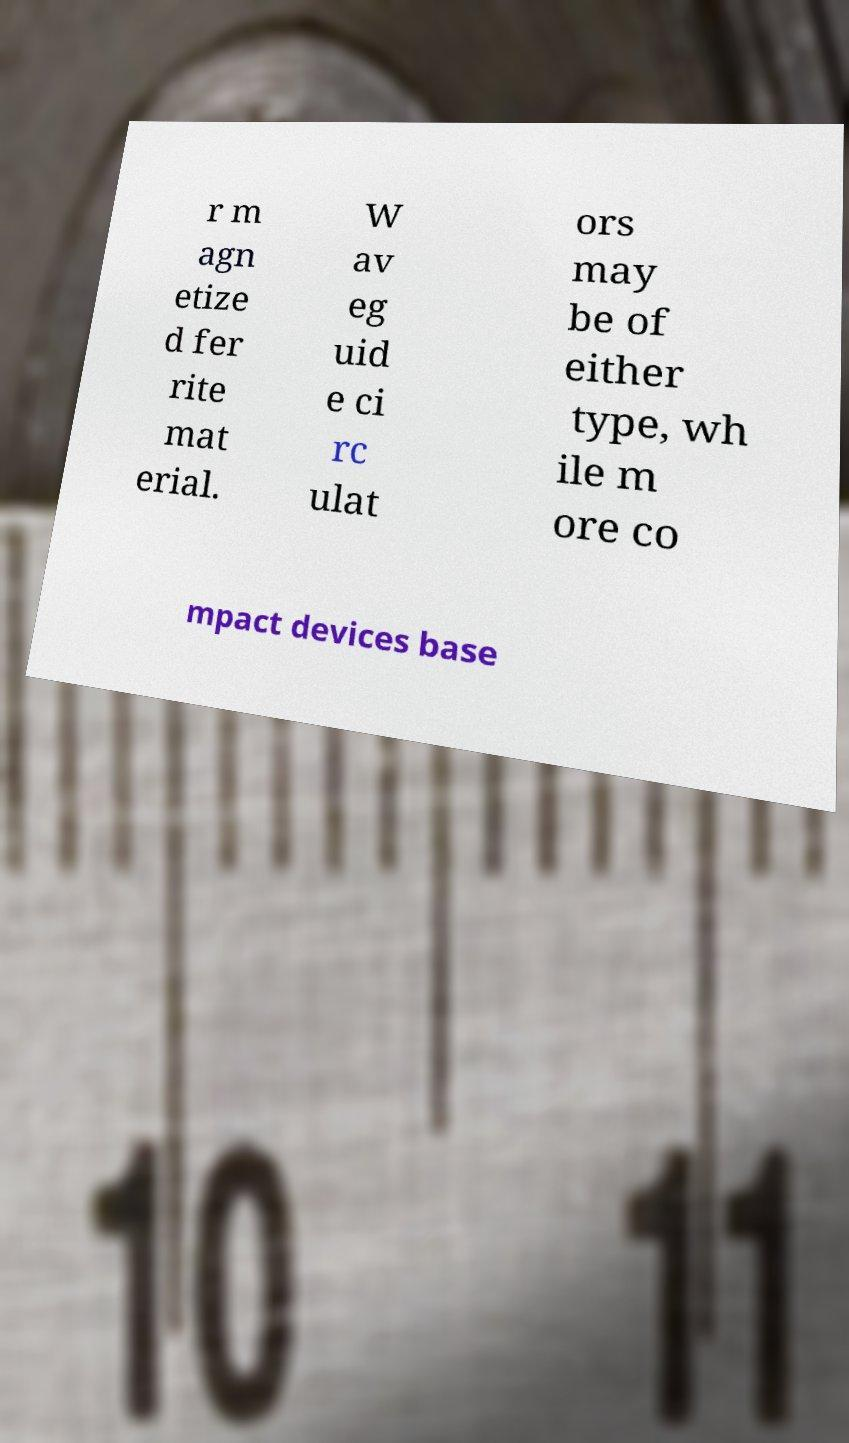Please identify and transcribe the text found in this image. r m agn etize d fer rite mat erial. W av eg uid e ci rc ulat ors may be of either type, wh ile m ore co mpact devices base 